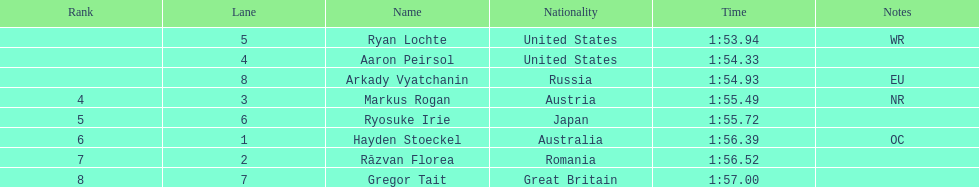What was the number of swimmers representing the us? 2. 